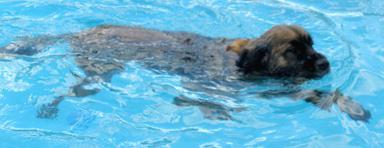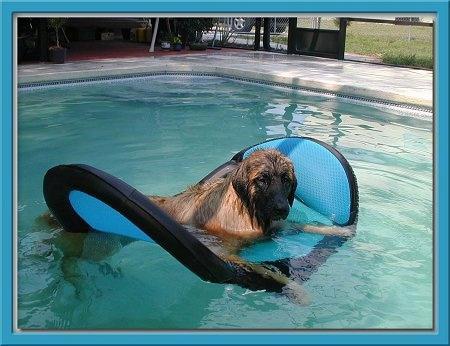The first image is the image on the left, the second image is the image on the right. For the images displayed, is the sentence "An image shows one forward-facing dog swimming in a natural body of water." factually correct? Answer yes or no. No. 